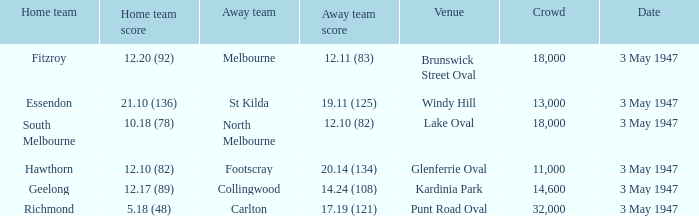10 (82)? Lake Oval. 